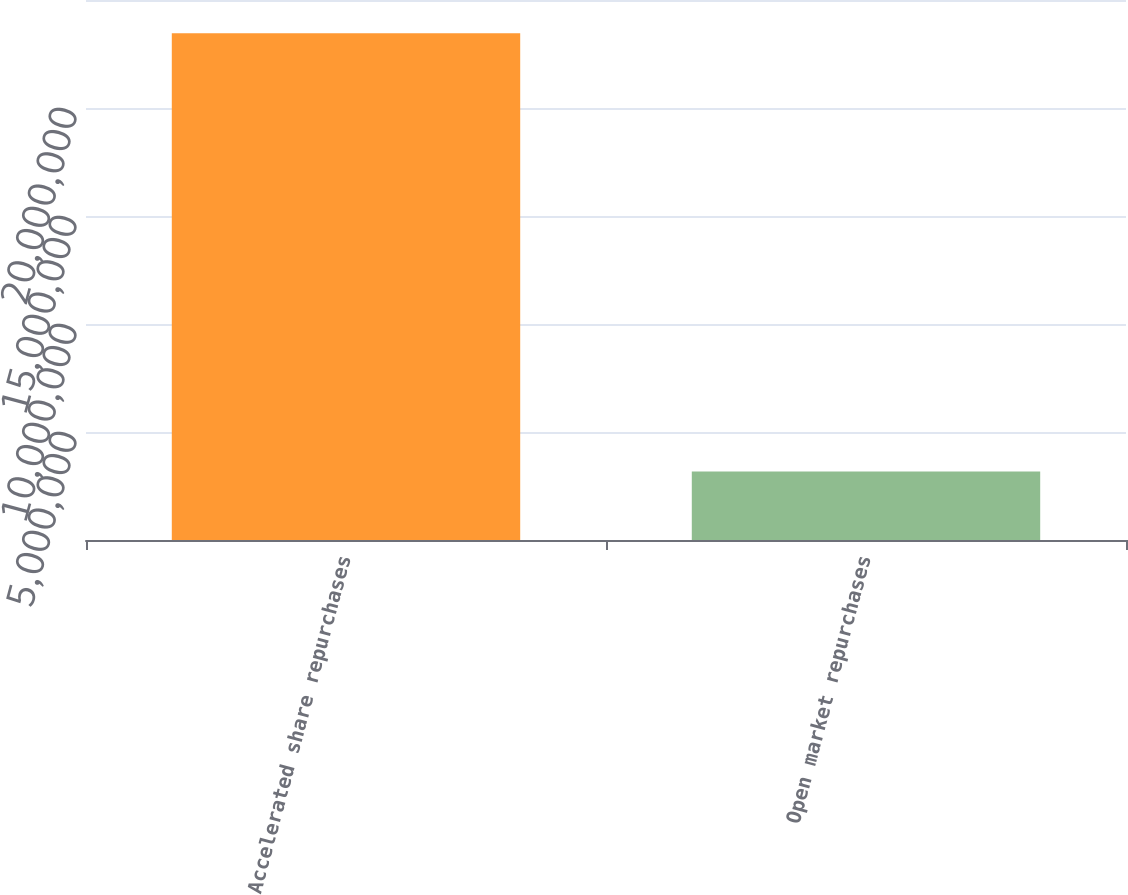Convert chart to OTSL. <chart><loc_0><loc_0><loc_500><loc_500><bar_chart><fcel>Accelerated share repurchases<fcel>Open market repurchases<nl><fcel>2.34551e+07<fcel>3.1717e+06<nl></chart> 